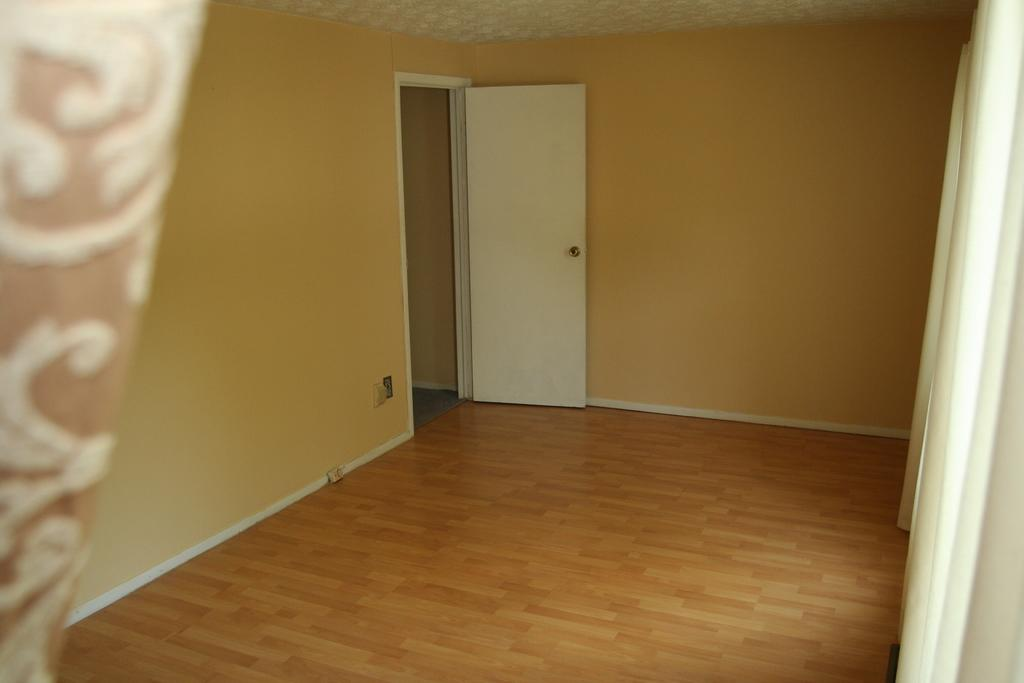What structure can be seen in the background of the image? There is a door in the background of the image. What is located at the top of the image? There is a roof at the top of the image. What type of window treatment is present on the right side of the image? There are curtains on the right side of the image. What type of window treatment is present on the left side of the image? There are curtains on the left side of the image. Can you tell me how many hydrants are visible in the image? There are no hydrants present in the image. What type of country is depicted in the image? The image does not depict a country; it features a door, roof, and curtains. 